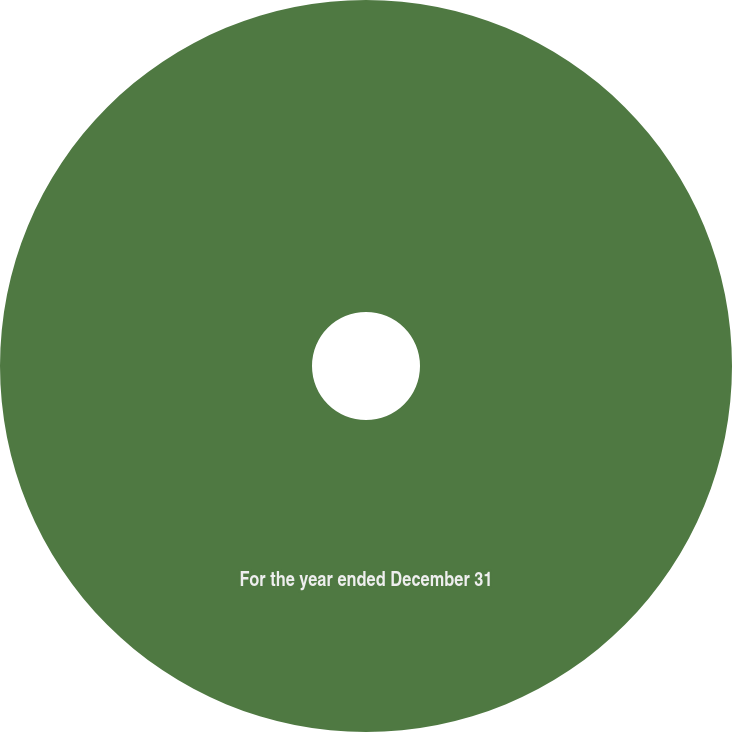<chart> <loc_0><loc_0><loc_500><loc_500><pie_chart><fcel>For the year ended December 31<nl><fcel>100.0%<nl></chart> 